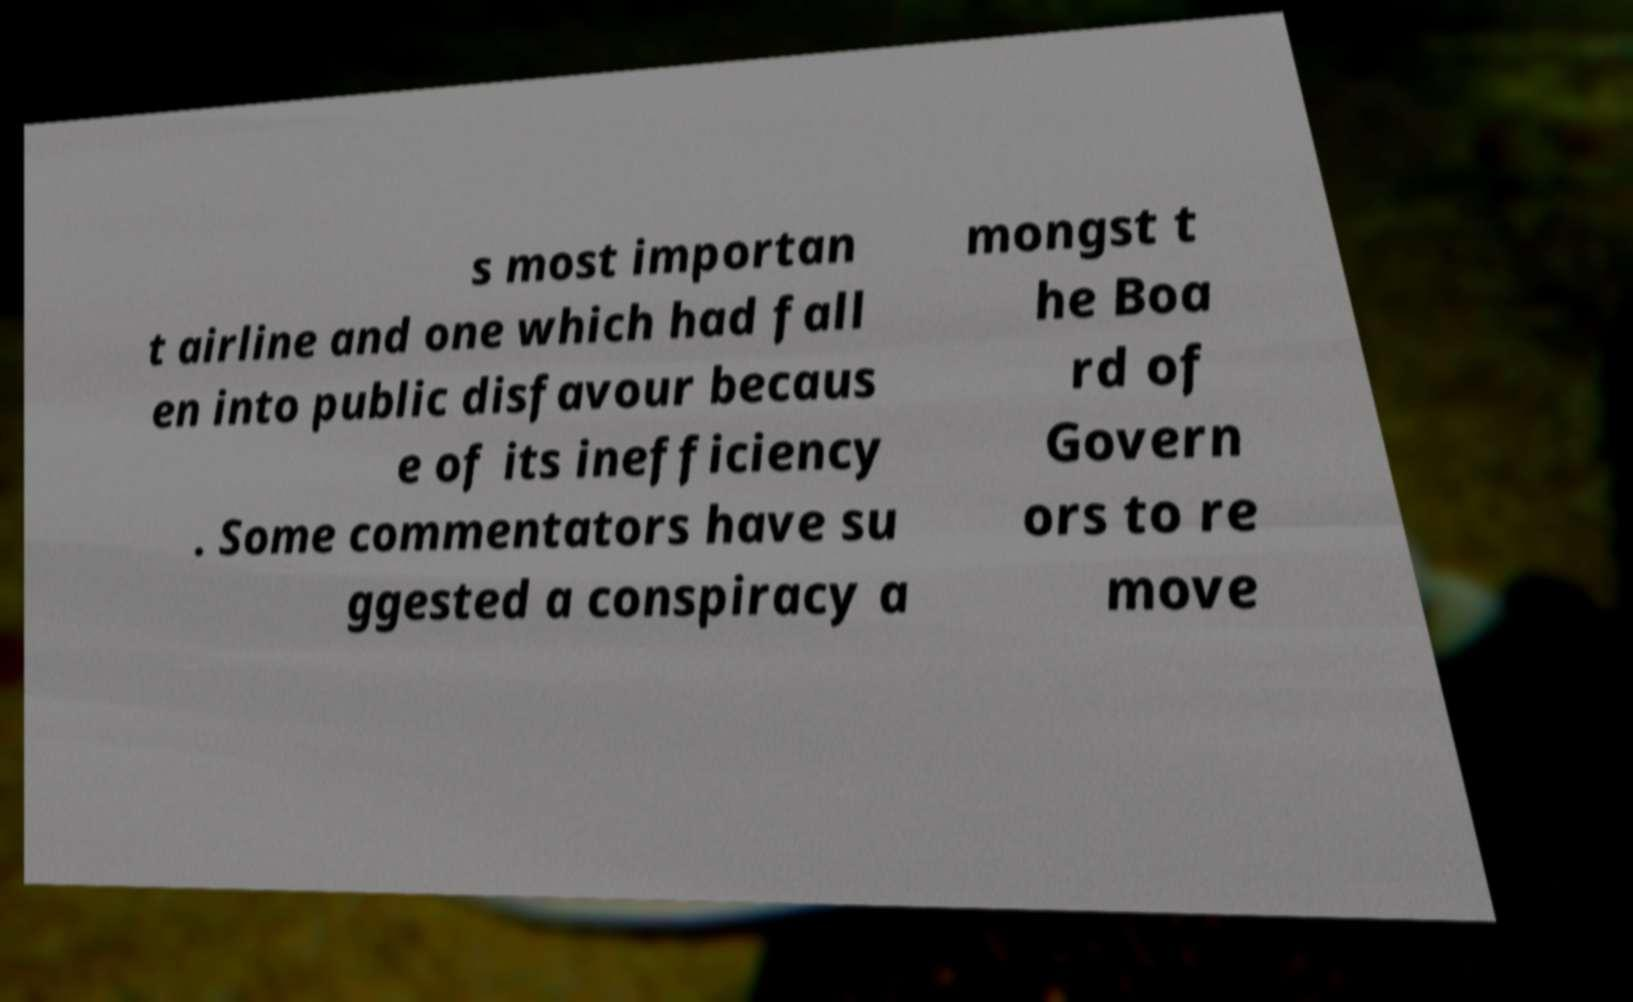Please read and relay the text visible in this image. What does it say? s most importan t airline and one which had fall en into public disfavour becaus e of its inefficiency . Some commentators have su ggested a conspiracy a mongst t he Boa rd of Govern ors to re move 